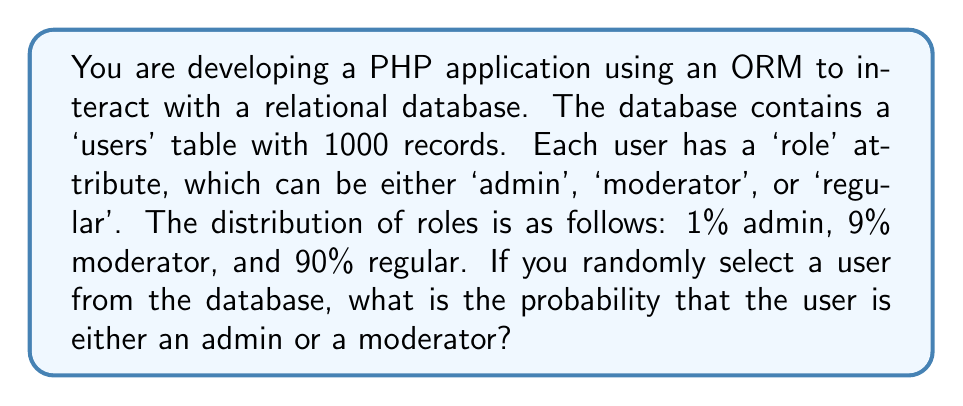Teach me how to tackle this problem. To solve this problem, we need to follow these steps:

1. Understand the given information:
   - Total number of users: 1000
   - Distribution of roles:
     - Admin: 1% = 0.01
     - Moderator: 9% = 0.09
     - Regular: 90% = 0.90

2. Calculate the probability of selecting an admin:
   $P(\text{admin}) = 0.01$

3. Calculate the probability of selecting a moderator:
   $P(\text{moderator}) = 0.09$

4. To find the probability of selecting either an admin or a moderator, we need to add these probabilities together:

   $$P(\text{admin or moderator}) = P(\text{admin}) + P(\text{moderator})$$
   $$P(\text{admin or moderator}) = 0.01 + 0.09 = 0.10$$

5. Convert the decimal to a percentage:
   $$0.10 \times 100\% = 10\%$$

This result means that if you randomly select a user from the database using your ORM, there is a 10% chance that the user will be either an admin or a moderator.
Answer: The probability of randomly selecting a user who is either an admin or a moderator is $0.10$ or $10\%$. 